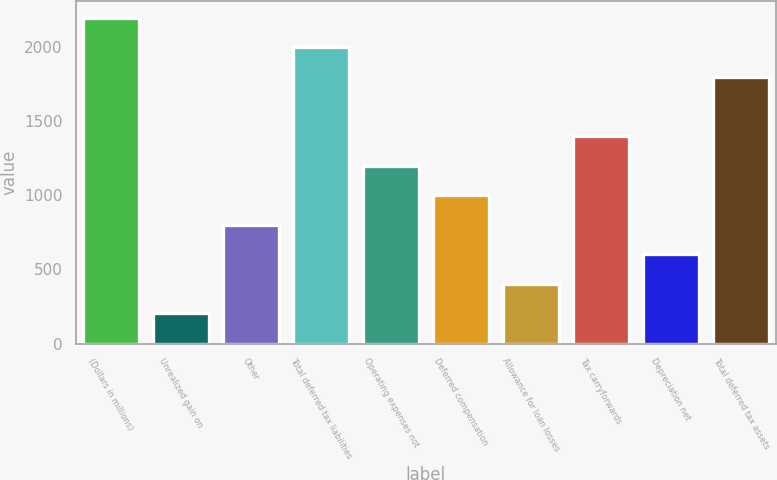Convert chart. <chart><loc_0><loc_0><loc_500><loc_500><bar_chart><fcel>(Dollars in millions)<fcel>Unrealized gain on<fcel>Other<fcel>Total deferred tax liabilities<fcel>Operating expenses not<fcel>Deferred compensation<fcel>Allowance for loan losses<fcel>Tax carryforwards<fcel>Depreciation net<fcel>Total deferred tax assets<nl><fcel>2199.7<fcel>202.7<fcel>801.8<fcel>2000<fcel>1201.2<fcel>1001.5<fcel>402.4<fcel>1400.9<fcel>602.1<fcel>1800.3<nl></chart> 